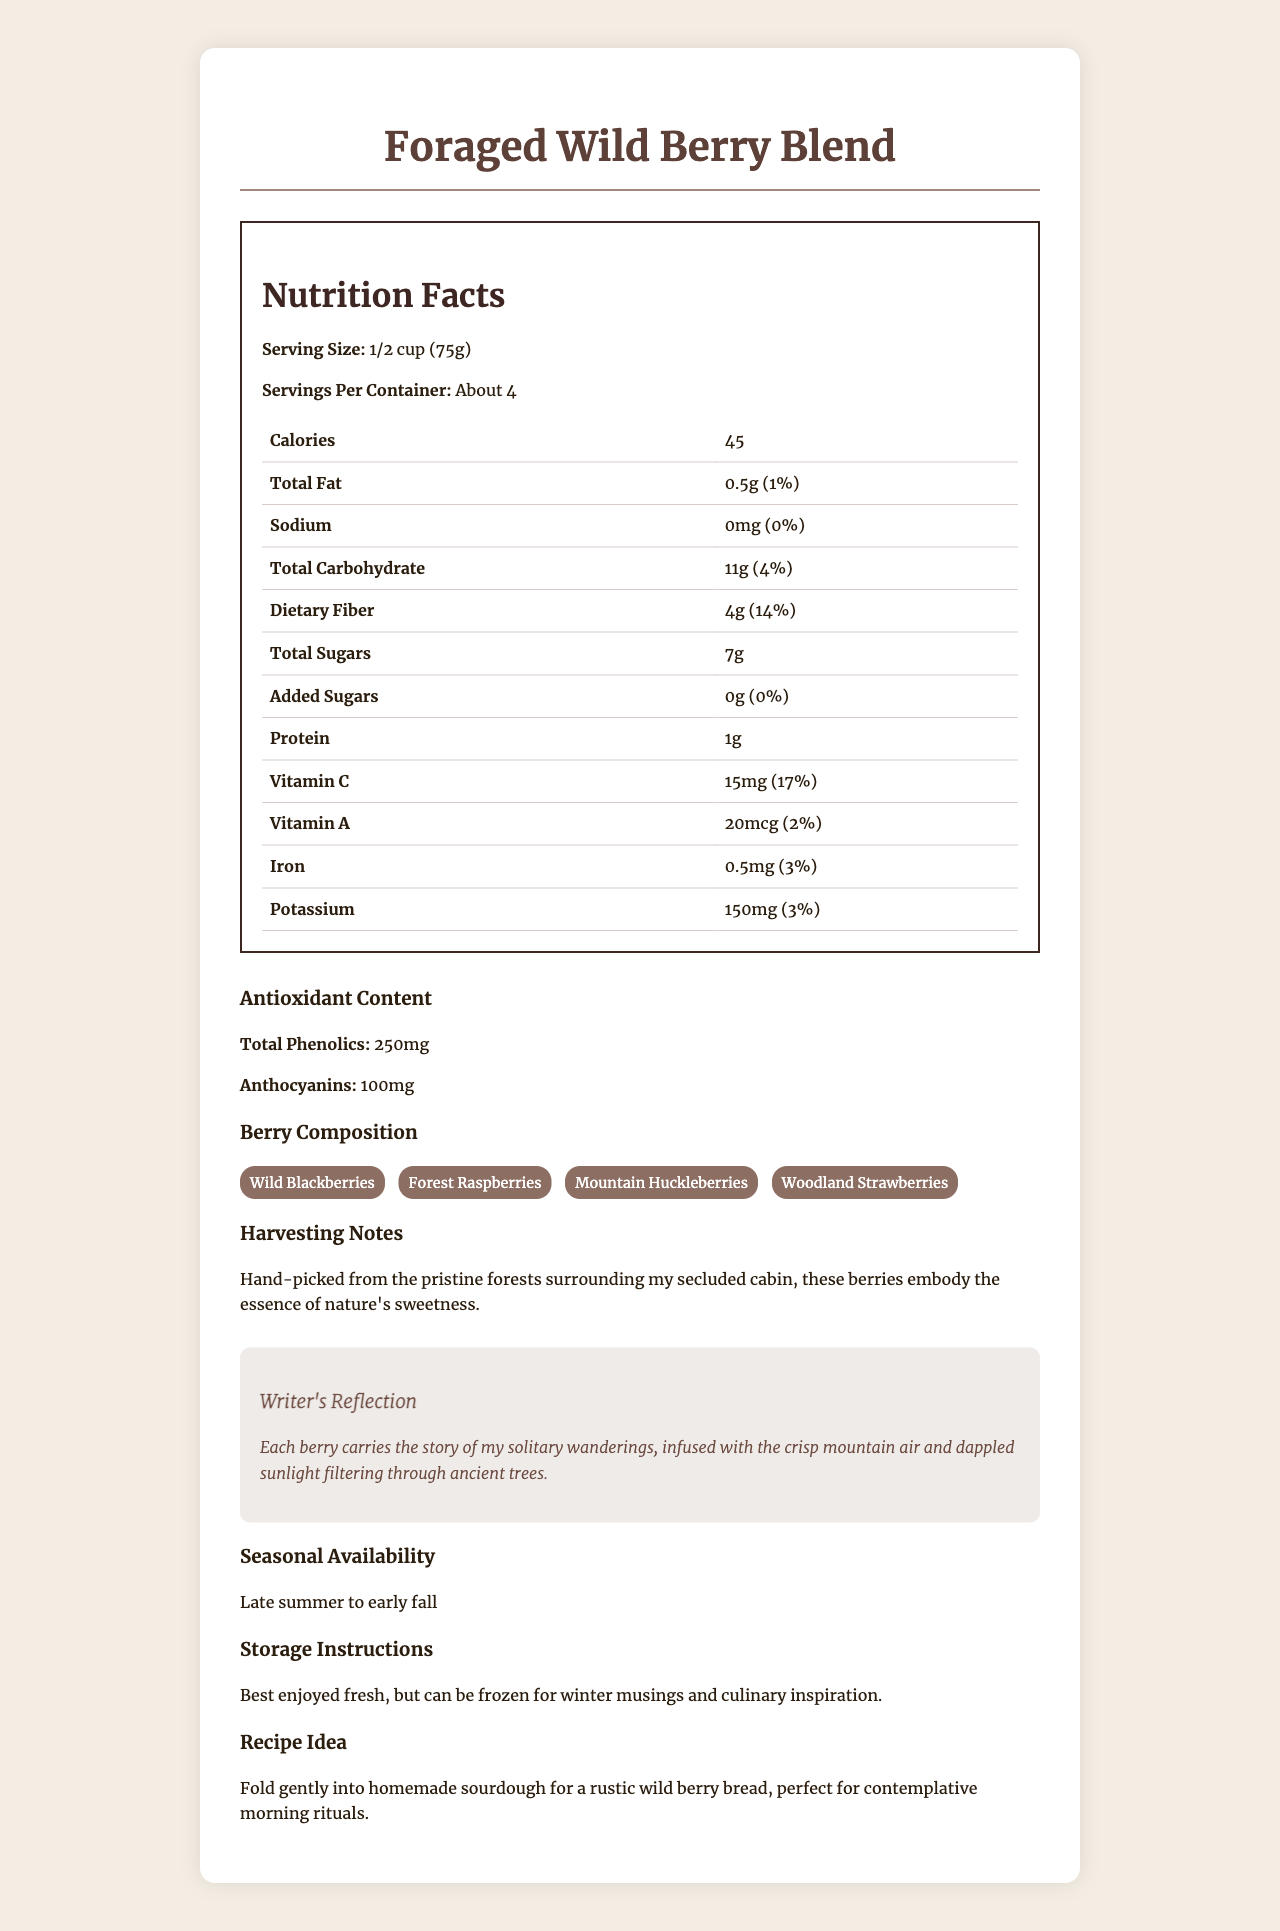what is the serving size? The serving size is explicitly stated under the "Nutrition Facts" section.
Answer: 1/2 cup (75g) how many servings are in the container? The number of servings per container is given under the "Nutrition Facts" section.
Answer: About 4 how many calories are there per serving? The calorie count per serving is listed under the "Nutrition Facts" section.
Answer: 45 how much dietary fiber is in one serving? The amount of dietary fiber per serving is provided in the "Nutrition Facts" section.
Answer: 4g how much vitamin C is in one serving? The amount of Vitamin C per serving is listed in the "Nutrition Facts" section.
Answer: 15mg which berry is not included in the composition? A. Wild Blackberries B. Forest Raspberries C. Blueberries D. Woodland Strawberries The "Berry Composition" section lists all the included berries, and Blueberries are not among them.
Answer: C. Blueberries what percentage of daily value does the total fat represent? A. 2% B. 1% C. 3% D. 5% The percentage daily value for total fat is listed as 1% in the "Nutrition Facts" section.
Answer: B. 1% does this product contain any added sugars? Yes/No The "Total Sugars" section mentions that there are 0g of added sugars.
Answer: No what are the antioxidant contents mentioned? The antioxidant content section lists total phenolics and anthocyanins with their respective amounts.
Answer: Total Phenolics: 250mg, Anthocyanins: 100mg how are the berries harvested? The "Harvesting Notes" mention that the berries are hand-picked from the pristine forests.
Answer: Hand-picked from the pristine forests surrounding the writer's secluded cabin what is the recommended storage method? The "Storage Instructions" section provides this information.
Answer: Best enjoyed fresh, but can be frozen for winter musings and culinary inspiration summarize the main idea of the document. The document includes nutrition details, berry composition, antioxidant content, harvesting notes, writer's reflections, and additional information related to storage and usage.
Answer: The document provides detailed nutrition facts and information about a "Foraged Wild Berry Blend," highlighting its natural sweetness, antioxidant content, and the writer's personal journey of harvesting these berries from the forest. can this product be enjoyed year-round? The document states the berries are seasonally available from late summer to early fall but does not mention if they are available year-round through other means.
Answer: Not enough information how does the writer describe the origin of the berries? This description is found in the "Writer's Reflection" section.
Answer: Each berry carries the story of solitary wanderings, infused with crisp mountain air and dappled sunlight filtering through ancient trees. 